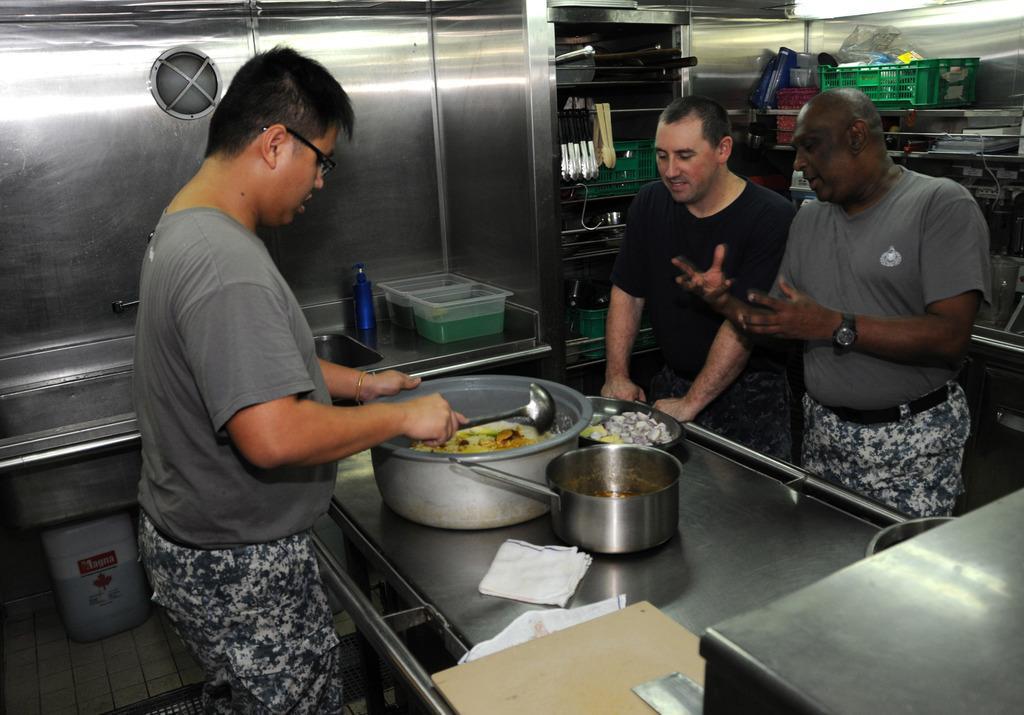Please provide a concise description of this image. There are 3 people here making food. On the right 2 people are talking to each other. In the background we see spoons,basket,cloth. 